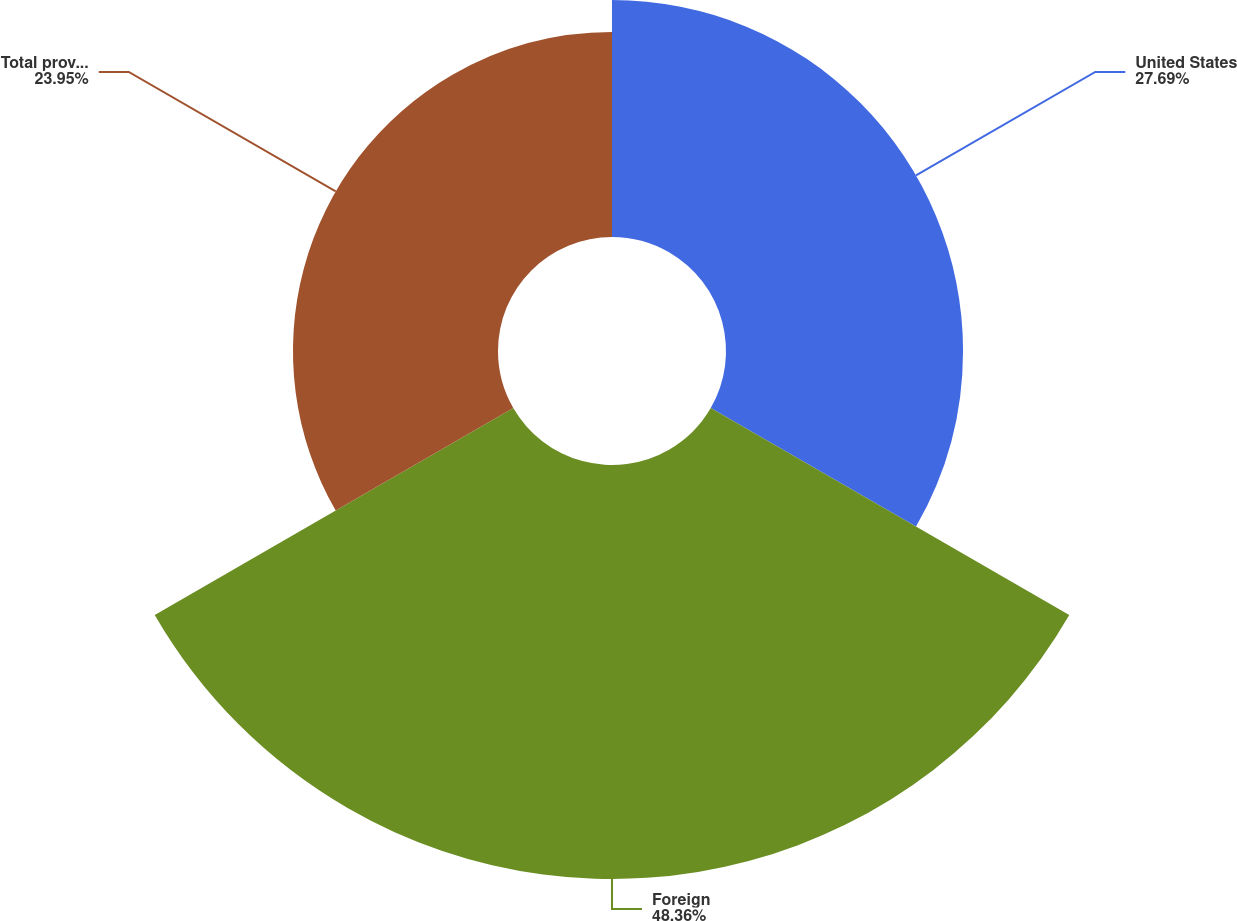Convert chart. <chart><loc_0><loc_0><loc_500><loc_500><pie_chart><fcel>United States<fcel>Foreign<fcel>Total provision for income<nl><fcel>27.69%<fcel>48.36%<fcel>23.95%<nl></chart> 